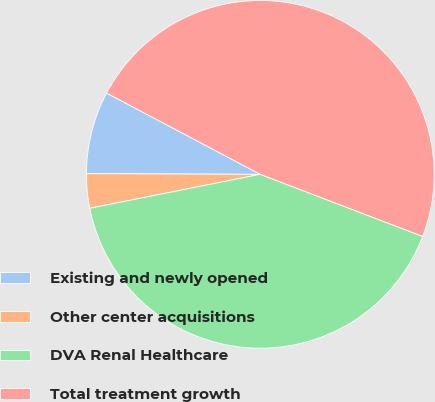Convert chart. <chart><loc_0><loc_0><loc_500><loc_500><pie_chart><fcel>Existing and newly opened<fcel>Other center acquisitions<fcel>DVA Renal Healthcare<fcel>Total treatment growth<nl><fcel>7.68%<fcel>3.19%<fcel>41.06%<fcel>48.07%<nl></chart> 